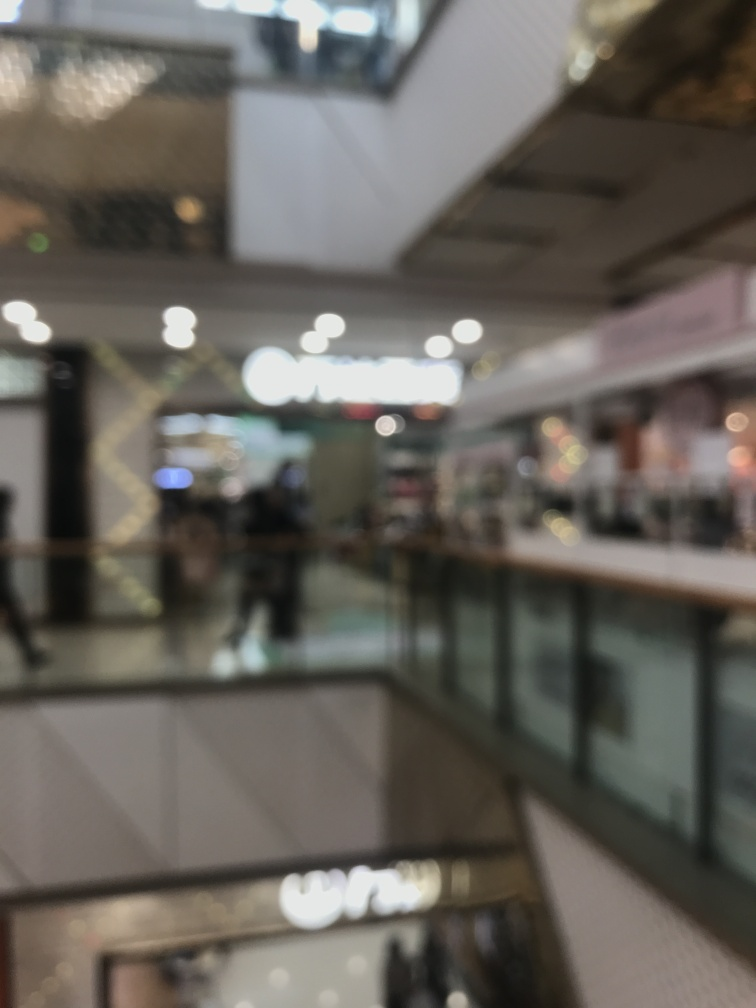What could be the reason for the image's blurriness? The blurriness of the image could be due to a number of reasons, such as camera shake during the exposure, an out-of-focus lens, or a deliberate artistic choice. If the photo was taken in a low-light environment, the camera's settings might have resulted in a longer exposure time, heightening the sensitivity to movement and leading to this blurred effect. 